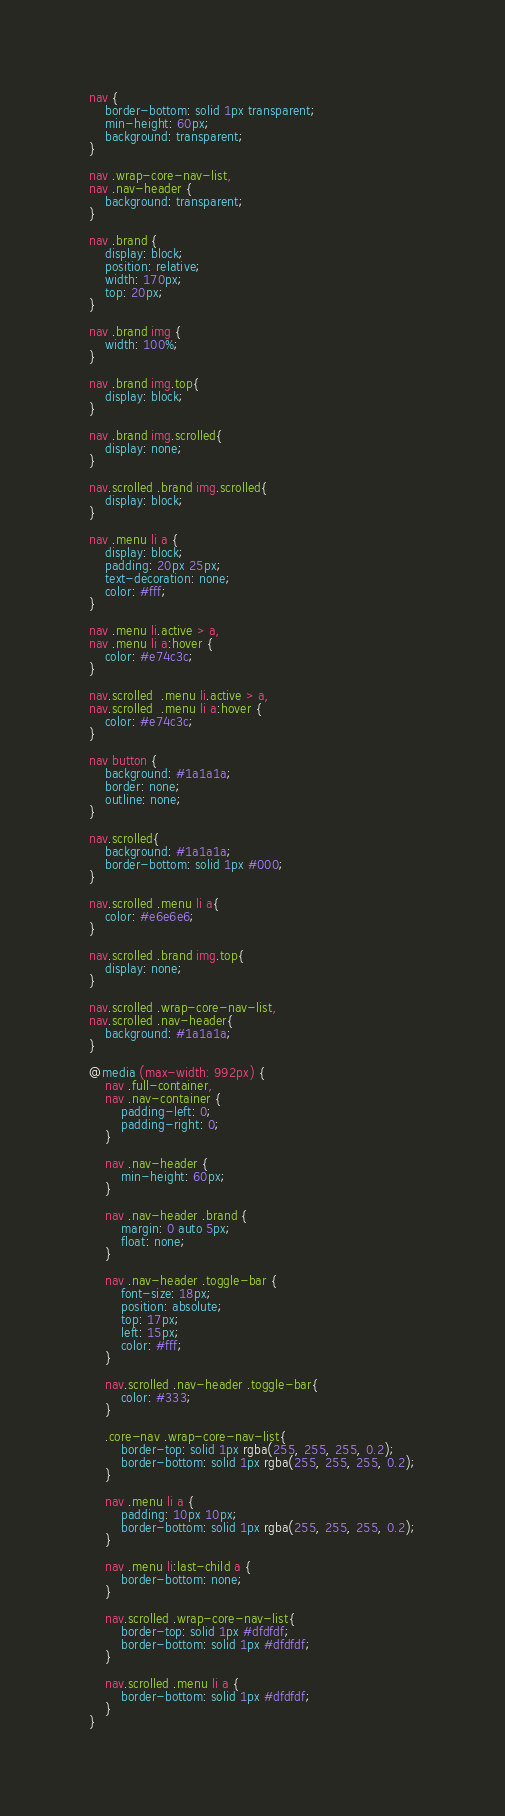<code> <loc_0><loc_0><loc_500><loc_500><_CSS_>nav {
    border-bottom: solid 1px transparent;
    min-height: 60px;
    background: transparent;
}

nav .wrap-core-nav-list,
nav .nav-header {
    background: transparent;
}

nav .brand {
    display: block;
    position: relative;
    width: 170px;
    top: 20px;
}

nav .brand img {
    width: 100%;
}

nav .brand img.top{
    display: block;
}

nav .brand img.scrolled{
    display: none;
}

nav.scrolled .brand img.scrolled{
    display: block;
}

nav .menu li a {
    display: block;
    padding: 20px 25px;
    text-decoration: none;
    color: #fff;
}

nav .menu li.active > a,
nav .menu li a:hover {
    color: #e74c3c;
}

nav.scrolled  .menu li.active > a,
nav.scrolled  .menu li a:hover {
	color: #e74c3c;
}

nav button {
    background: #1a1a1a;
    border: none;
    outline: none;
}

nav.scrolled{
    background: #1a1a1a;
    border-bottom: solid 1px #000;
}

nav.scrolled .menu li a{
    color: #e6e6e6;
}

nav.scrolled .brand img.top{
    display: none;
}

nav.scrolled .wrap-core-nav-list,
nav.scrolled .nav-header{
    background: #1a1a1a;
}

@media (max-width: 992px) {
    nav .full-container,
    nav .nav-container {
        padding-left: 0;
        padding-right: 0;
    }

    nav .nav-header {
        min-height: 60px;
    }

    nav .nav-header .brand {
        margin: 0 auto 5px;
        float: none;
    }

    nav .nav-header .toggle-bar {
        font-size: 18px;
        position: absolute;
        top: 17px;
        left: 15px;
        color: #fff;
    }

    nav.scrolled .nav-header .toggle-bar{
        color: #333;
    }

    .core-nav .wrap-core-nav-list{
        border-top: solid 1px rgba(255, 255, 255, 0.2);
        border-bottom: solid 1px rgba(255, 255, 255, 0.2);
    }

    nav .menu li a {
        padding: 10px 10px;
        border-bottom: solid 1px rgba(255, 255, 255, 0.2);
    }

    nav .menu li:last-child a {
        border-bottom: none;
    }

    nav.scrolled .wrap-core-nav-list{
        border-top: solid 1px #dfdfdf;
        border-bottom: solid 1px #dfdfdf;
    }

    nav.scrolled .menu li a {
        border-bottom: solid 1px #dfdfdf;
    }
}
</code> 